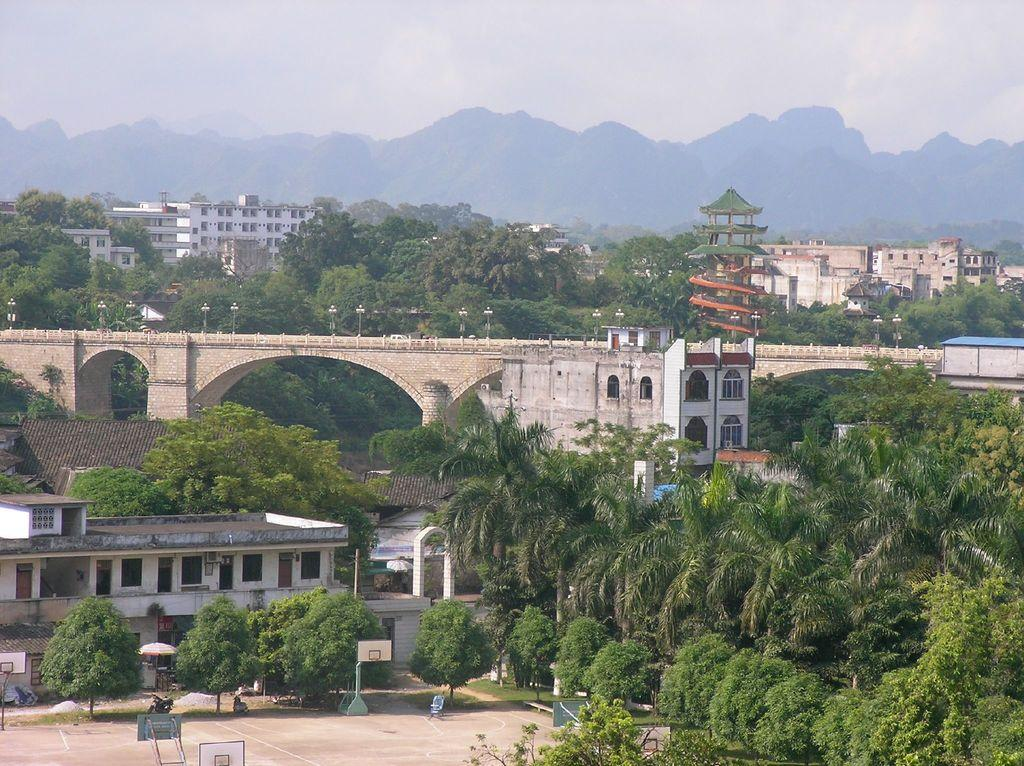What type of structures are visible in the image? There are buildings with windows in the image. What other natural elements can be seen in the image? There are trees and mountains in the image. What is visible in the background of the image? The sky is visible in the background of the image. What can be observed in the sky? Clouds are present in the sky. What type of meat is being grilled on the sticks in the image? There are no sticks or meat present in the image; it features buildings, trees, mountains, and a sky with clouds. 